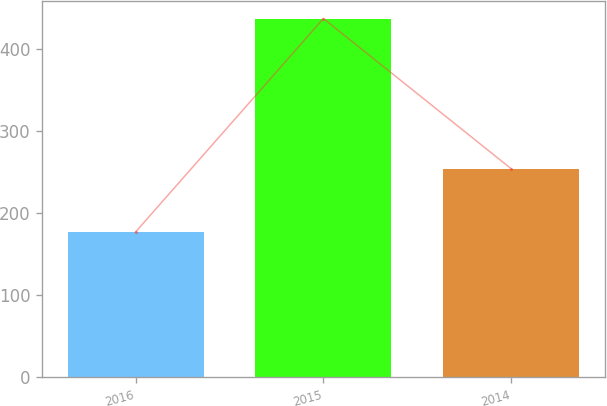Convert chart to OTSL. <chart><loc_0><loc_0><loc_500><loc_500><bar_chart><fcel>2016<fcel>2015<fcel>2014<nl><fcel>177<fcel>437<fcel>254<nl></chart> 